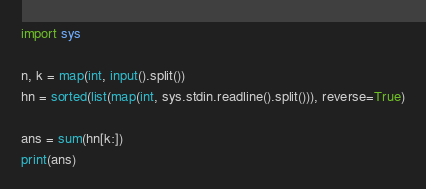Convert code to text. <code><loc_0><loc_0><loc_500><loc_500><_Python_>import sys

n, k = map(int, input().split())
hn = sorted(list(map(int, sys.stdin.readline().split())), reverse=True)

ans = sum(hn[k:])
print(ans)</code> 